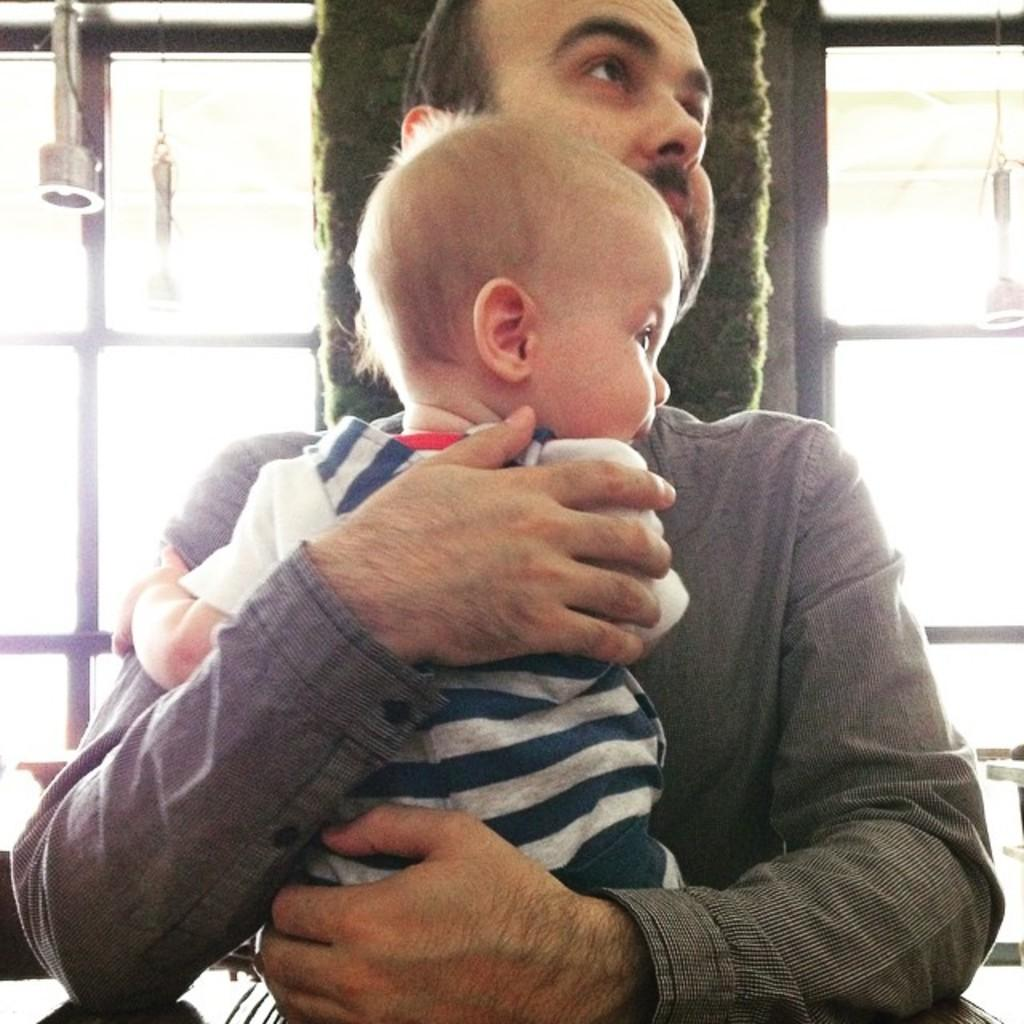Who is present in the image? There is a man in the image. What is the man holding in the image? The man is holding a baby. What can be seen in the background of the image? There are windows visible in the background of the image. Where is the nest located in the image? There is no nest present in the image. What sound can be heard coming from the baby in the image? The image is a still picture, so no sounds can be heard. 